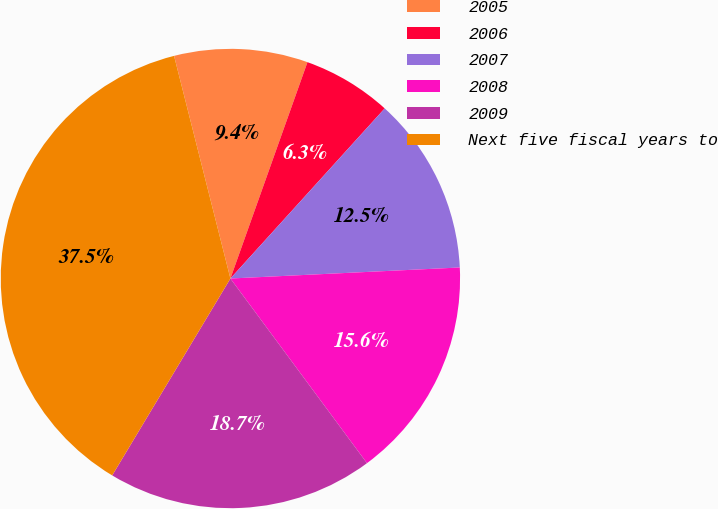Convert chart. <chart><loc_0><loc_0><loc_500><loc_500><pie_chart><fcel>2005<fcel>2006<fcel>2007<fcel>2008<fcel>2009<fcel>Next five fiscal years to<nl><fcel>9.39%<fcel>6.28%<fcel>12.51%<fcel>15.63%<fcel>18.74%<fcel>37.45%<nl></chart> 